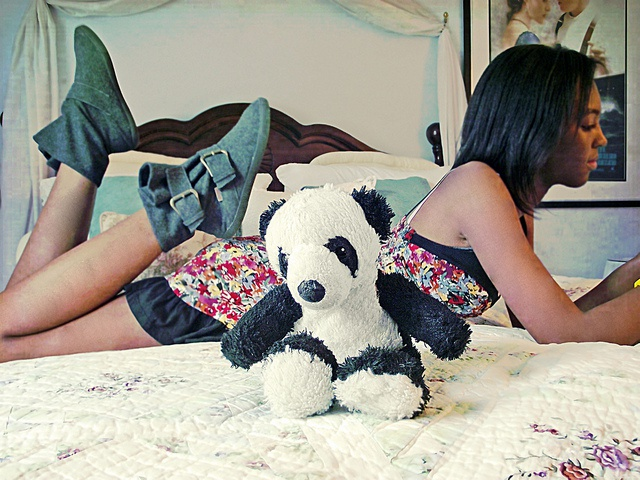Describe the objects in this image and their specific colors. I can see bed in gray, beige, darkgray, and black tones, people in gray, black, tan, brown, and darkgray tones, teddy bear in gray, beige, black, lightgray, and darkgray tones, and people in gray, darkgray, and olive tones in this image. 